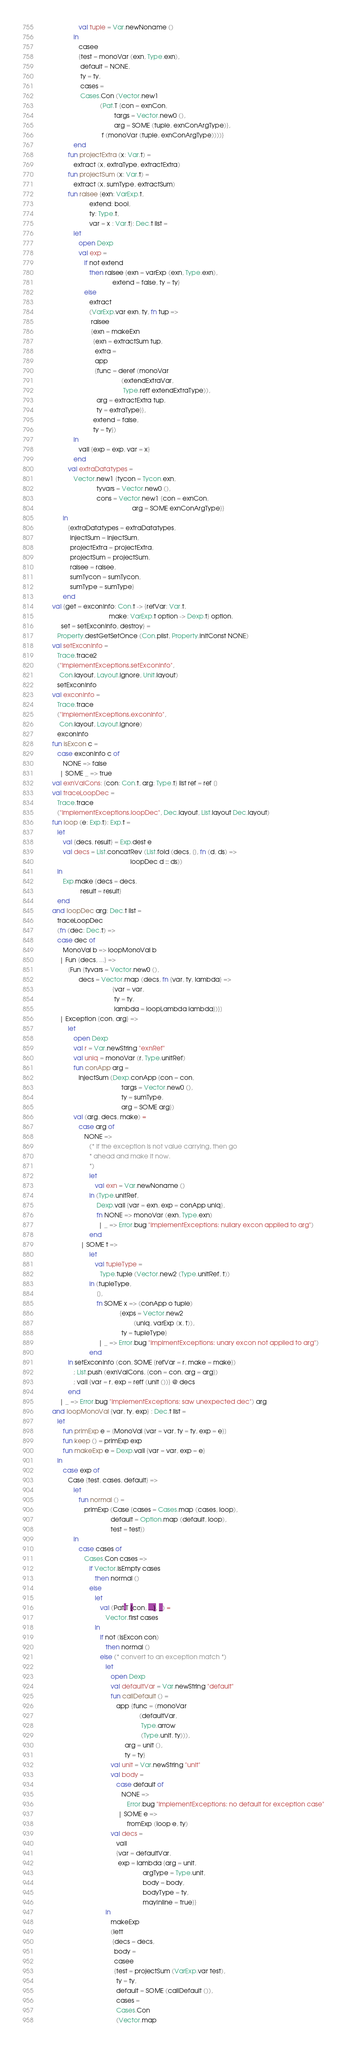Convert code to text. <code><loc_0><loc_0><loc_500><loc_500><_SML_>                     val tuple = Var.newNoname ()
                  in
                     casee
                     {test = monoVar (exn, Type.exn),
                      default = NONE,
                      ty = ty,
                      cases =
                      Cases.Con (Vector.new1
                                 (Pat.T {con = exnCon,
                                         targs = Vector.new0 (),
                                         arg = SOME (tuple, exnConArgType)},
                                  f (monoVar (tuple, exnConArgType))))}
                  end
               fun projectExtra (x: Var.t) =
                  extract (x, extraType, extractExtra)
               fun projectSum (x: Var.t) =
                  extract (x, sumType, extractSum)
               fun raisee {exn: VarExp.t,
                           extend: bool,
                           ty: Type.t,
                           var = x : Var.t}: Dec.t list =
                  let
                     open Dexp
                     val exp =
                        if not extend
                           then raisee {exn = varExp (exn, Type.exn),
                                        extend = false, ty = ty}
                        else
                           extract
                           (VarExp.var exn, ty, fn tup =>
                            raisee
                            {exn = makeExn
                             {exn = extractSum tup,
                              extra =
                              app
                              {func = deref (monoVar
                                             (extendExtraVar,
                                              Type.reff extendExtraType)),
                               arg = extractExtra tup,
                               ty = extraType}},
                             extend = false,
                             ty = ty})
                  in
                     vall {exp = exp, var = x}
                  end
               val extraDatatypes =
                  Vector.new1 {tycon = Tycon.exn,
                               tyvars = Vector.new0 (),
                               cons = Vector.new1 {con = exnCon,
                                                   arg = SOME exnConArgType}}
            in
               {extraDatatypes = extraDatatypes,
                injectSum = injectSum,
                projectExtra = projectExtra,
                projectSum = projectSum,
                raisee = raisee,
                sumTycon = sumTycon,
                sumType = sumType}
            end
      val {get = exconInfo: Con.t -> {refVar: Var.t,
                                      make: VarExp.t option -> Dexp.t} option,
           set = setExconInfo, destroy} =
         Property.destGetSetOnce (Con.plist, Property.initConst NONE)
      val setExconInfo = 
         Trace.trace2 
         ("ImplementExceptions.setExconInfo", 
          Con.layout, Layout.ignore, Unit.layout) 
         setExconInfo
      val exconInfo =
         Trace.trace 
         ("ImplementExceptions.exconInfo", 
          Con.layout, Layout.ignore) 
         exconInfo
      fun isExcon c =
         case exconInfo c of
            NONE => false
          | SOME _ => true
      val exnValCons: {con: Con.t, arg: Type.t} list ref = ref []
      val traceLoopDec =
         Trace.trace
         ("ImplementExceptions.loopDec", Dec.layout, List.layout Dec.layout)
      fun loop (e: Exp.t): Exp.t =
         let
            val {decs, result} = Exp.dest e
            val decs = List.concatRev (List.fold (decs, [], fn (d, ds) =>
                                                  loopDec d :: ds))
         in
            Exp.make {decs = decs,
                      result = result}
         end
      and loopDec arg: Dec.t list =
         traceLoopDec
         (fn (dec: Dec.t) =>
         case dec of
            MonoVal b => loopMonoVal b
          | Fun {decs, ...} =>
               [Fun {tyvars = Vector.new0 (),
                     decs = Vector.map (decs, fn {var, ty, lambda} =>
                                        {var = var,
                                         ty = ty,
                                         lambda = loopLambda lambda})}]
          | Exception {con, arg} =>
               let
                  open Dexp
                  val r = Var.newString "exnRef"
                  val uniq = monoVar (r, Type.unitRef)
                  fun conApp arg =
                     injectSum (Dexp.conApp {con = con,
                                             targs = Vector.new0 (),
                                             ty = sumType,
                                             arg = SOME arg})
                  val (arg, decs, make) =
                     case arg of
                        NONE =>
                           (* If the exception is not value carrying, then go
                            * ahead and make it now.
                            *)
                           let
                              val exn = Var.newNoname ()
                           in (Type.unitRef,
                               Dexp.vall {var = exn, exp = conApp uniq},
                               fn NONE => monoVar (exn, Type.exn)
                                | _ => Error.bug "ImplementExceptions: nullary excon applied to arg")
                           end
                      | SOME t =>
                           let
                              val tupleType =
                                 Type.tuple (Vector.new2 (Type.unitRef, t))
                           in (tupleType,
                               [],
                               fn SOME x => (conApp o tuple)
                                            {exps = Vector.new2
                                                    (uniq, varExp (x, t)),
                                             ty = tupleType}
                                | _ => Error.bug "ImplmentExceptions: unary excon not applied to arg")
                           end
               in setExconInfo (con, SOME {refVar = r, make = make})
                  ; List.push (exnValCons, {con = con, arg = arg})
                  ; vall {var = r, exp = reff (unit ())} @ decs
               end
          | _ => Error.bug "ImplementExceptions: saw unexpected dec") arg
      and loopMonoVal {var, ty, exp} : Dec.t list =
         let
            fun primExp e = [MonoVal {var = var, ty = ty, exp = e}]
            fun keep () = primExp exp
            fun makeExp e = Dexp.vall {var = var, exp = e}
         in
            case exp of
               Case {test, cases, default} =>
                  let
                     fun normal () =
                        primExp (Case {cases = Cases.map (cases, loop),
                                       default = Option.map (default, loop),
                                       test = test})
                  in
                     case cases of
                        Cases.Con cases =>
                           if Vector.isEmpty cases
                              then normal ()
                           else
                              let
                                 val (Pat.T {con, ...}, _) =
                                    Vector.first cases
                              in
                                 if not (isExcon con)
                                    then normal ()
                                 else (* convert to an exception match *)
                                    let
                                       open Dexp
                                       val defaultVar = Var.newString "default"
                                       fun callDefault () =
                                          app {func = (monoVar
                                                       (defaultVar,
                                                        Type.arrow
                                                        (Type.unit, ty))),
                                               arg = unit (),
                                               ty = ty}
                                       val unit = Var.newString "unit"
                                       val body =
                                          case default of
                                             NONE =>
                                                Error.bug "ImplementExceptions: no default for exception case"
                                           | SOME e =>
                                                fromExp (loop e, ty)
                                       val decs =
                                          vall
                                          {var = defaultVar,
                                           exp = lambda {arg = unit,
                                                         argType = Type.unit,
                                                         body = body,
                                                         bodyType = ty,
                                                         mayInline = true}}
                                    in
                                       makeExp
                                       (lett
                                        {decs = decs,
                                         body =
                                         casee
                                         {test = projectSum (VarExp.var test),
                                          ty = ty,
                                          default = SOME (callDefault ()),
                                          cases =
                                          Cases.Con
                                          (Vector.map</code> 